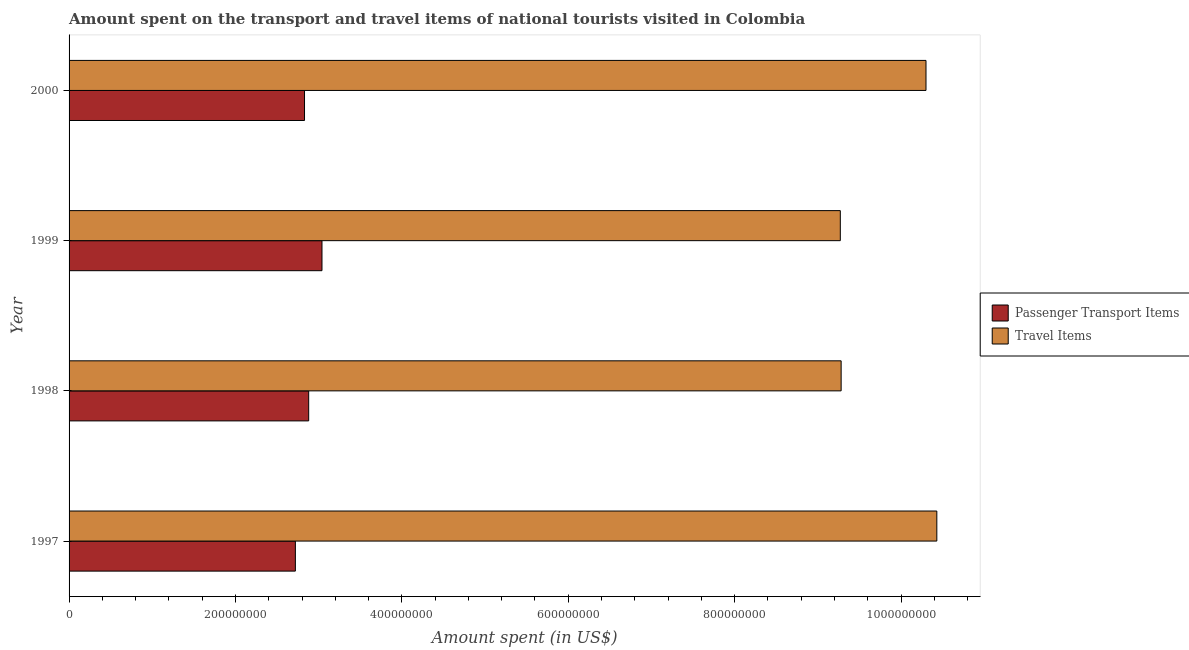Are the number of bars per tick equal to the number of legend labels?
Provide a short and direct response. Yes. Are the number of bars on each tick of the Y-axis equal?
Your response must be concise. Yes. What is the label of the 4th group of bars from the top?
Make the answer very short. 1997. In how many cases, is the number of bars for a given year not equal to the number of legend labels?
Your answer should be compact. 0. What is the amount spent on passenger transport items in 2000?
Keep it short and to the point. 2.83e+08. Across all years, what is the maximum amount spent on passenger transport items?
Offer a terse response. 3.04e+08. Across all years, what is the minimum amount spent on passenger transport items?
Your answer should be compact. 2.72e+08. In which year was the amount spent on passenger transport items maximum?
Your answer should be compact. 1999. What is the total amount spent on passenger transport items in the graph?
Make the answer very short. 1.15e+09. What is the difference between the amount spent on passenger transport items in 1998 and that in 1999?
Offer a very short reply. -1.60e+07. What is the difference between the amount spent in travel items in 1998 and the amount spent on passenger transport items in 2000?
Your answer should be very brief. 6.45e+08. What is the average amount spent on passenger transport items per year?
Ensure brevity in your answer.  2.87e+08. In the year 1999, what is the difference between the amount spent on passenger transport items and amount spent in travel items?
Provide a short and direct response. -6.23e+08. What is the ratio of the amount spent in travel items in 1999 to that in 2000?
Give a very brief answer. 0.9. Is the amount spent on passenger transport items in 1997 less than that in 1999?
Your response must be concise. Yes. Is the difference between the amount spent in travel items in 1999 and 2000 greater than the difference between the amount spent on passenger transport items in 1999 and 2000?
Offer a very short reply. No. What is the difference between the highest and the second highest amount spent on passenger transport items?
Provide a short and direct response. 1.60e+07. What is the difference between the highest and the lowest amount spent in travel items?
Ensure brevity in your answer.  1.16e+08. Is the sum of the amount spent on passenger transport items in 1997 and 1999 greater than the maximum amount spent in travel items across all years?
Your answer should be very brief. No. What does the 1st bar from the top in 1999 represents?
Make the answer very short. Travel Items. What does the 2nd bar from the bottom in 1997 represents?
Your response must be concise. Travel Items. How many years are there in the graph?
Keep it short and to the point. 4. Does the graph contain any zero values?
Your answer should be compact. No. How many legend labels are there?
Offer a very short reply. 2. How are the legend labels stacked?
Provide a succinct answer. Vertical. What is the title of the graph?
Offer a terse response. Amount spent on the transport and travel items of national tourists visited in Colombia. Does "Research and Development" appear as one of the legend labels in the graph?
Give a very brief answer. No. What is the label or title of the X-axis?
Make the answer very short. Amount spent (in US$). What is the label or title of the Y-axis?
Your answer should be very brief. Year. What is the Amount spent (in US$) in Passenger Transport Items in 1997?
Ensure brevity in your answer.  2.72e+08. What is the Amount spent (in US$) in Travel Items in 1997?
Offer a terse response. 1.04e+09. What is the Amount spent (in US$) in Passenger Transport Items in 1998?
Provide a succinct answer. 2.88e+08. What is the Amount spent (in US$) in Travel Items in 1998?
Your answer should be compact. 9.28e+08. What is the Amount spent (in US$) in Passenger Transport Items in 1999?
Give a very brief answer. 3.04e+08. What is the Amount spent (in US$) of Travel Items in 1999?
Keep it short and to the point. 9.27e+08. What is the Amount spent (in US$) of Passenger Transport Items in 2000?
Offer a terse response. 2.83e+08. What is the Amount spent (in US$) in Travel Items in 2000?
Offer a very short reply. 1.03e+09. Across all years, what is the maximum Amount spent (in US$) of Passenger Transport Items?
Give a very brief answer. 3.04e+08. Across all years, what is the maximum Amount spent (in US$) in Travel Items?
Keep it short and to the point. 1.04e+09. Across all years, what is the minimum Amount spent (in US$) of Passenger Transport Items?
Your answer should be very brief. 2.72e+08. Across all years, what is the minimum Amount spent (in US$) in Travel Items?
Give a very brief answer. 9.27e+08. What is the total Amount spent (in US$) of Passenger Transport Items in the graph?
Your answer should be compact. 1.15e+09. What is the total Amount spent (in US$) in Travel Items in the graph?
Your response must be concise. 3.93e+09. What is the difference between the Amount spent (in US$) of Passenger Transport Items in 1997 and that in 1998?
Provide a short and direct response. -1.60e+07. What is the difference between the Amount spent (in US$) of Travel Items in 1997 and that in 1998?
Make the answer very short. 1.15e+08. What is the difference between the Amount spent (in US$) of Passenger Transport Items in 1997 and that in 1999?
Your response must be concise. -3.20e+07. What is the difference between the Amount spent (in US$) in Travel Items in 1997 and that in 1999?
Provide a succinct answer. 1.16e+08. What is the difference between the Amount spent (in US$) in Passenger Transport Items in 1997 and that in 2000?
Offer a very short reply. -1.10e+07. What is the difference between the Amount spent (in US$) of Travel Items in 1997 and that in 2000?
Ensure brevity in your answer.  1.30e+07. What is the difference between the Amount spent (in US$) of Passenger Transport Items in 1998 and that in 1999?
Ensure brevity in your answer.  -1.60e+07. What is the difference between the Amount spent (in US$) of Passenger Transport Items in 1998 and that in 2000?
Your answer should be very brief. 5.00e+06. What is the difference between the Amount spent (in US$) of Travel Items in 1998 and that in 2000?
Your answer should be very brief. -1.02e+08. What is the difference between the Amount spent (in US$) in Passenger Transport Items in 1999 and that in 2000?
Give a very brief answer. 2.10e+07. What is the difference between the Amount spent (in US$) in Travel Items in 1999 and that in 2000?
Offer a terse response. -1.03e+08. What is the difference between the Amount spent (in US$) of Passenger Transport Items in 1997 and the Amount spent (in US$) of Travel Items in 1998?
Your answer should be compact. -6.56e+08. What is the difference between the Amount spent (in US$) in Passenger Transport Items in 1997 and the Amount spent (in US$) in Travel Items in 1999?
Offer a terse response. -6.55e+08. What is the difference between the Amount spent (in US$) of Passenger Transport Items in 1997 and the Amount spent (in US$) of Travel Items in 2000?
Keep it short and to the point. -7.58e+08. What is the difference between the Amount spent (in US$) of Passenger Transport Items in 1998 and the Amount spent (in US$) of Travel Items in 1999?
Keep it short and to the point. -6.39e+08. What is the difference between the Amount spent (in US$) of Passenger Transport Items in 1998 and the Amount spent (in US$) of Travel Items in 2000?
Ensure brevity in your answer.  -7.42e+08. What is the difference between the Amount spent (in US$) of Passenger Transport Items in 1999 and the Amount spent (in US$) of Travel Items in 2000?
Your response must be concise. -7.26e+08. What is the average Amount spent (in US$) of Passenger Transport Items per year?
Give a very brief answer. 2.87e+08. What is the average Amount spent (in US$) in Travel Items per year?
Provide a succinct answer. 9.82e+08. In the year 1997, what is the difference between the Amount spent (in US$) of Passenger Transport Items and Amount spent (in US$) of Travel Items?
Provide a short and direct response. -7.71e+08. In the year 1998, what is the difference between the Amount spent (in US$) of Passenger Transport Items and Amount spent (in US$) of Travel Items?
Provide a short and direct response. -6.40e+08. In the year 1999, what is the difference between the Amount spent (in US$) of Passenger Transport Items and Amount spent (in US$) of Travel Items?
Provide a succinct answer. -6.23e+08. In the year 2000, what is the difference between the Amount spent (in US$) of Passenger Transport Items and Amount spent (in US$) of Travel Items?
Provide a short and direct response. -7.47e+08. What is the ratio of the Amount spent (in US$) in Passenger Transport Items in 1997 to that in 1998?
Provide a succinct answer. 0.94. What is the ratio of the Amount spent (in US$) of Travel Items in 1997 to that in 1998?
Keep it short and to the point. 1.12. What is the ratio of the Amount spent (in US$) of Passenger Transport Items in 1997 to that in 1999?
Give a very brief answer. 0.89. What is the ratio of the Amount spent (in US$) of Travel Items in 1997 to that in 1999?
Ensure brevity in your answer.  1.13. What is the ratio of the Amount spent (in US$) in Passenger Transport Items in 1997 to that in 2000?
Give a very brief answer. 0.96. What is the ratio of the Amount spent (in US$) in Travel Items in 1997 to that in 2000?
Provide a short and direct response. 1.01. What is the ratio of the Amount spent (in US$) of Passenger Transport Items in 1998 to that in 1999?
Give a very brief answer. 0.95. What is the ratio of the Amount spent (in US$) of Travel Items in 1998 to that in 1999?
Offer a terse response. 1. What is the ratio of the Amount spent (in US$) in Passenger Transport Items in 1998 to that in 2000?
Offer a terse response. 1.02. What is the ratio of the Amount spent (in US$) of Travel Items in 1998 to that in 2000?
Your answer should be compact. 0.9. What is the ratio of the Amount spent (in US$) of Passenger Transport Items in 1999 to that in 2000?
Ensure brevity in your answer.  1.07. What is the difference between the highest and the second highest Amount spent (in US$) in Passenger Transport Items?
Make the answer very short. 1.60e+07. What is the difference between the highest and the second highest Amount spent (in US$) of Travel Items?
Offer a very short reply. 1.30e+07. What is the difference between the highest and the lowest Amount spent (in US$) in Passenger Transport Items?
Your answer should be very brief. 3.20e+07. What is the difference between the highest and the lowest Amount spent (in US$) of Travel Items?
Make the answer very short. 1.16e+08. 